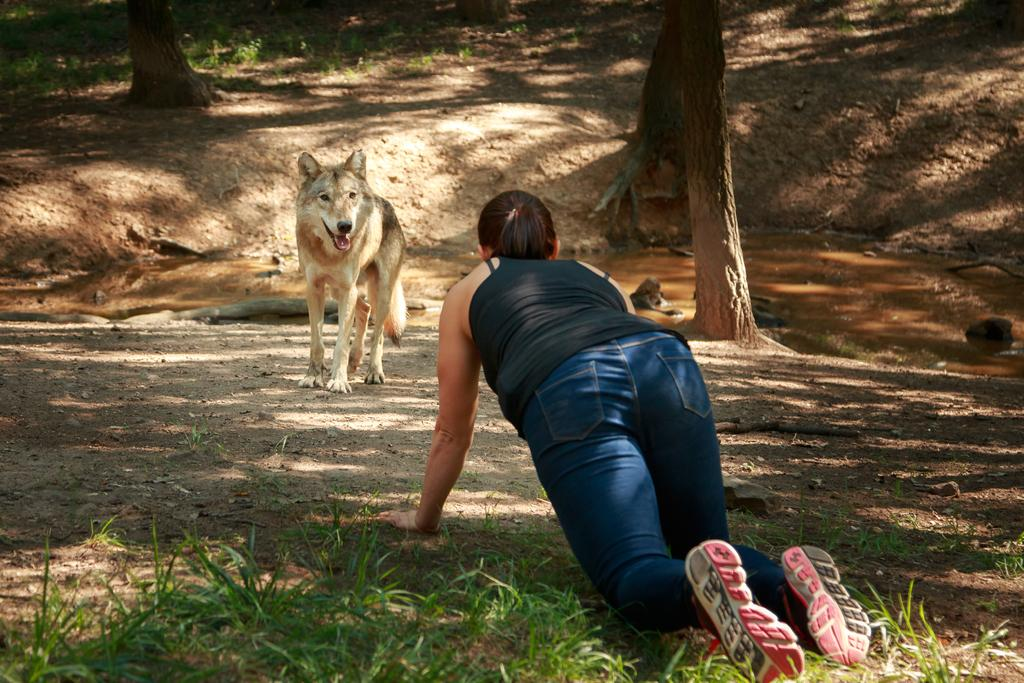What type of animal is in the image? There is a dog in the image. Who else is present in the image? There is a woman in the image. What type of terrain is visible in the image? There is grass in the image. What natural element can be seen in the image? There is water visible in the image. What part of the trees can be seen in the image? The bark of trees is present in the image. What type of force is being applied to the pancake in the image? There is no pancake present in the image, so no force can be applied to it. 